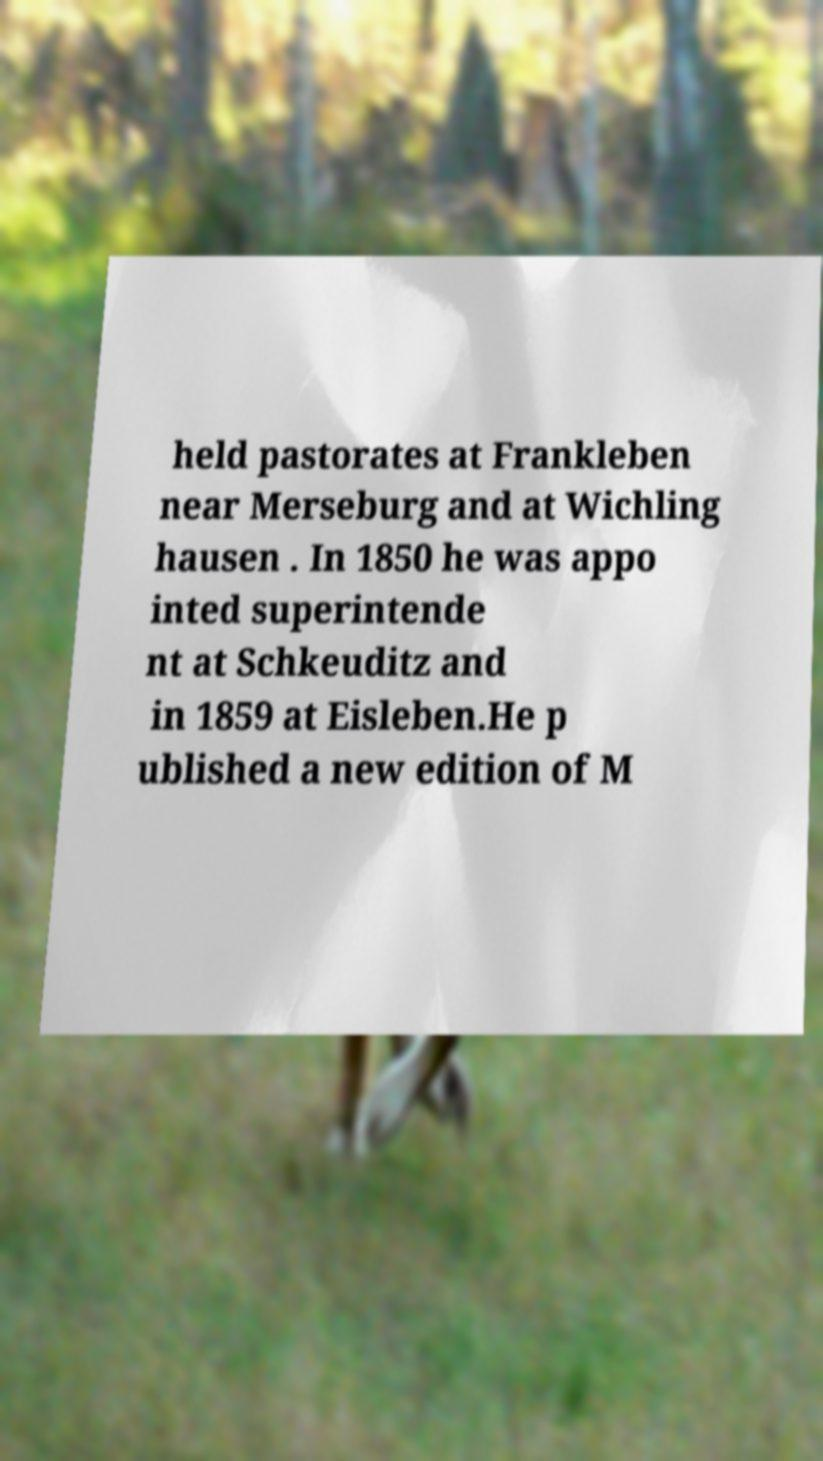Can you read and provide the text displayed in the image?This photo seems to have some interesting text. Can you extract and type it out for me? held pastorates at Frankleben near Merseburg and at Wichling hausen . In 1850 he was appo inted superintende nt at Schkeuditz and in 1859 at Eisleben.He p ublished a new edition of M 